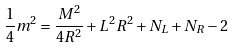Convert formula to latex. <formula><loc_0><loc_0><loc_500><loc_500>\frac { 1 } { 4 } m ^ { 2 } = \frac { M ^ { 2 } } { 4 R ^ { 2 } } + L ^ { 2 } R ^ { 2 } + N _ { L } + N _ { R } - 2</formula> 